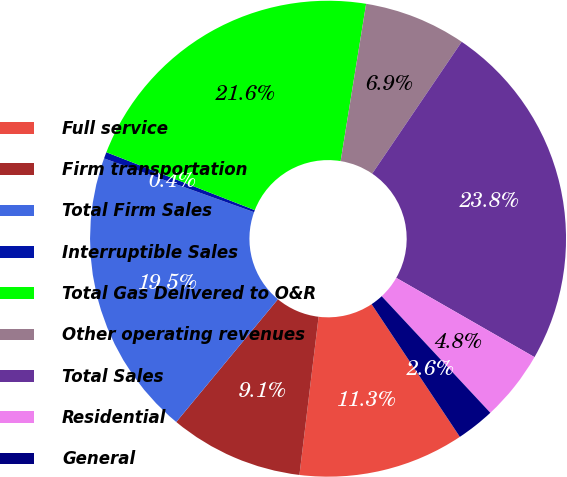Convert chart. <chart><loc_0><loc_0><loc_500><loc_500><pie_chart><fcel>Full service<fcel>Firm transportation<fcel>Total Firm Sales<fcel>Interruptible Sales<fcel>Total Gas Delivered to O&R<fcel>Other operating revenues<fcel>Total Sales<fcel>Residential<fcel>General<nl><fcel>11.26%<fcel>9.09%<fcel>19.47%<fcel>0.44%<fcel>21.64%<fcel>6.93%<fcel>23.8%<fcel>4.77%<fcel>2.6%<nl></chart> 